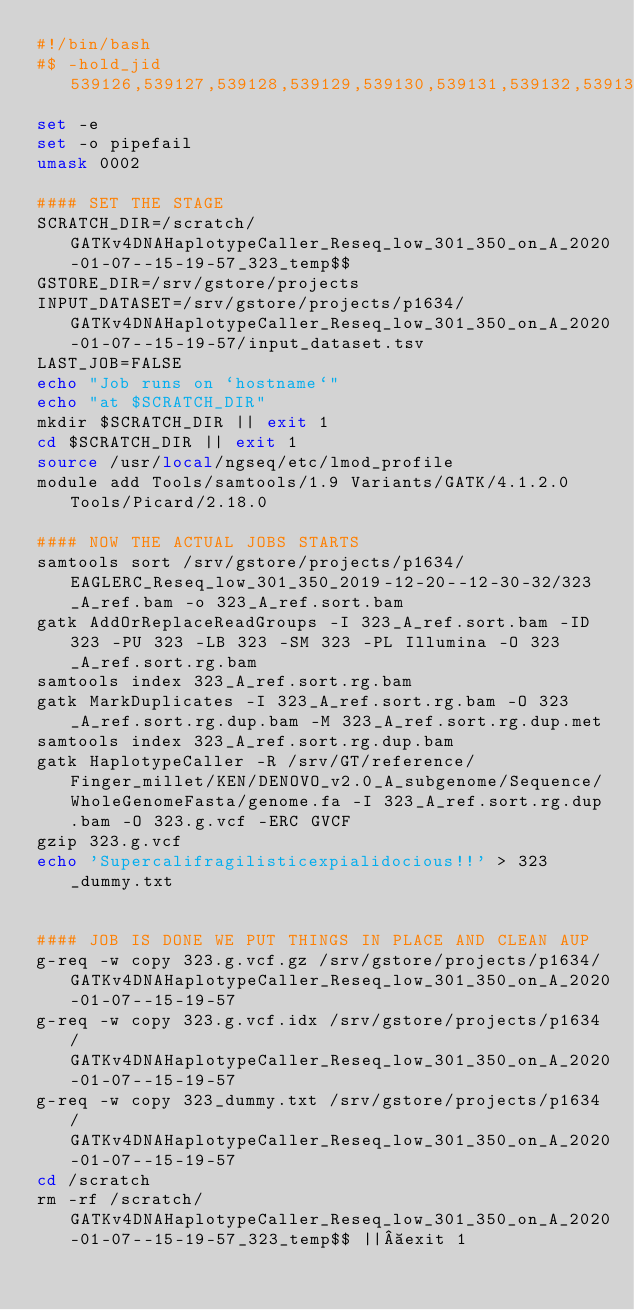<code> <loc_0><loc_0><loc_500><loc_500><_Bash_>#!/bin/bash
#$ -hold_jid 539126,539127,539128,539129,539130,539131,539132,539133,539134,539135,539136,539137,539138,539139,539140,539141,539142,539143,539144,539145,539146,539147,539148,539149,539150,539151,539152,539153,539154,539155,539156,539157,539158,539159,539160,539161,539162,539163,539164,539165,539166,539167,539168,539169,539170,539171,539172,539173,539174,539175
set -e
set -o pipefail
umask 0002

#### SET THE STAGE
SCRATCH_DIR=/scratch/GATKv4DNAHaplotypeCaller_Reseq_low_301_350_on_A_2020-01-07--15-19-57_323_temp$$
GSTORE_DIR=/srv/gstore/projects
INPUT_DATASET=/srv/gstore/projects/p1634/GATKv4DNAHaplotypeCaller_Reseq_low_301_350_on_A_2020-01-07--15-19-57/input_dataset.tsv
LAST_JOB=FALSE
echo "Job runs on `hostname`"
echo "at $SCRATCH_DIR"
mkdir $SCRATCH_DIR || exit 1
cd $SCRATCH_DIR || exit 1
source /usr/local/ngseq/etc/lmod_profile
module add Tools/samtools/1.9 Variants/GATK/4.1.2.0 Tools/Picard/2.18.0

#### NOW THE ACTUAL JOBS STARTS
samtools sort /srv/gstore/projects/p1634/EAGLERC_Reseq_low_301_350_2019-12-20--12-30-32/323_A_ref.bam -o 323_A_ref.sort.bam
gatk AddOrReplaceReadGroups -I 323_A_ref.sort.bam -ID 323 -PU 323 -LB 323 -SM 323 -PL Illumina -O 323_A_ref.sort.rg.bam
samtools index 323_A_ref.sort.rg.bam
gatk MarkDuplicates -I 323_A_ref.sort.rg.bam -O 323_A_ref.sort.rg.dup.bam -M 323_A_ref.sort.rg.dup.met
samtools index 323_A_ref.sort.rg.dup.bam
gatk HaplotypeCaller -R /srv/GT/reference/Finger_millet/KEN/DENOVO_v2.0_A_subgenome/Sequence/WholeGenomeFasta/genome.fa -I 323_A_ref.sort.rg.dup.bam -O 323.g.vcf -ERC GVCF
gzip 323.g.vcf
echo 'Supercalifragilisticexpialidocious!!' > 323_dummy.txt


#### JOB IS DONE WE PUT THINGS IN PLACE AND CLEAN AUP
g-req -w copy 323.g.vcf.gz /srv/gstore/projects/p1634/GATKv4DNAHaplotypeCaller_Reseq_low_301_350_on_A_2020-01-07--15-19-57
g-req -w copy 323.g.vcf.idx /srv/gstore/projects/p1634/GATKv4DNAHaplotypeCaller_Reseq_low_301_350_on_A_2020-01-07--15-19-57
g-req -w copy 323_dummy.txt /srv/gstore/projects/p1634/GATKv4DNAHaplotypeCaller_Reseq_low_301_350_on_A_2020-01-07--15-19-57
cd /scratch
rm -rf /scratch/GATKv4DNAHaplotypeCaller_Reseq_low_301_350_on_A_2020-01-07--15-19-57_323_temp$$ || exit 1

</code> 